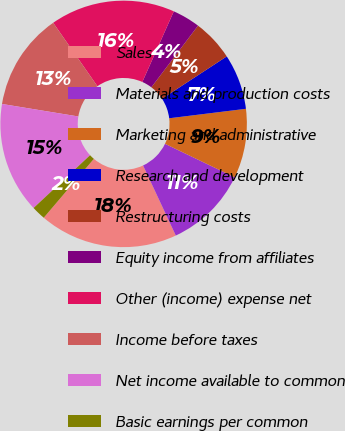Convert chart to OTSL. <chart><loc_0><loc_0><loc_500><loc_500><pie_chart><fcel>Sales<fcel>Materials and production costs<fcel>Marketing and administrative<fcel>Research and development<fcel>Restructuring costs<fcel>Equity income from affiliates<fcel>Other (income) expense net<fcel>Income before taxes<fcel>Net income available to common<fcel>Basic earnings per common<nl><fcel>18.18%<fcel>10.91%<fcel>9.09%<fcel>7.27%<fcel>5.46%<fcel>3.64%<fcel>16.36%<fcel>12.73%<fcel>14.54%<fcel>1.82%<nl></chart> 